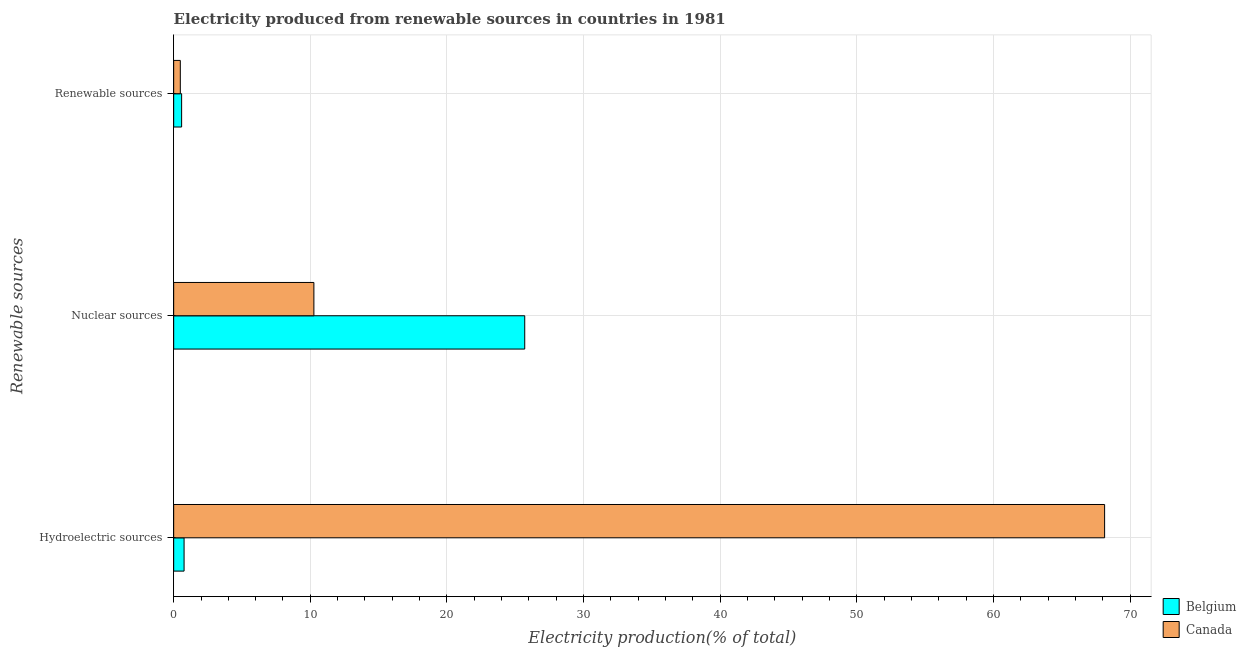How many bars are there on the 2nd tick from the top?
Keep it short and to the point. 2. What is the label of the 2nd group of bars from the top?
Keep it short and to the point. Nuclear sources. What is the percentage of electricity produced by renewable sources in Canada?
Provide a succinct answer. 0.49. Across all countries, what is the maximum percentage of electricity produced by nuclear sources?
Keep it short and to the point. 25.69. Across all countries, what is the minimum percentage of electricity produced by nuclear sources?
Your answer should be compact. 10.26. In which country was the percentage of electricity produced by nuclear sources minimum?
Make the answer very short. Canada. What is the total percentage of electricity produced by hydroelectric sources in the graph?
Offer a very short reply. 68.89. What is the difference between the percentage of electricity produced by renewable sources in Canada and that in Belgium?
Provide a succinct answer. -0.1. What is the difference between the percentage of electricity produced by nuclear sources in Belgium and the percentage of electricity produced by hydroelectric sources in Canada?
Provide a short and direct response. -42.44. What is the average percentage of electricity produced by renewable sources per country?
Your answer should be very brief. 0.53. What is the difference between the percentage of electricity produced by nuclear sources and percentage of electricity produced by renewable sources in Canada?
Offer a terse response. 9.78. What is the ratio of the percentage of electricity produced by renewable sources in Belgium to that in Canada?
Keep it short and to the point. 1.2. Is the difference between the percentage of electricity produced by hydroelectric sources in Canada and Belgium greater than the difference between the percentage of electricity produced by renewable sources in Canada and Belgium?
Offer a terse response. Yes. What is the difference between the highest and the second highest percentage of electricity produced by hydroelectric sources?
Your response must be concise. 67.37. What is the difference between the highest and the lowest percentage of electricity produced by nuclear sources?
Keep it short and to the point. 15.43. What does the 1st bar from the top in Renewable sources represents?
Give a very brief answer. Canada. How many bars are there?
Give a very brief answer. 6. Are the values on the major ticks of X-axis written in scientific E-notation?
Give a very brief answer. No. Where does the legend appear in the graph?
Offer a very short reply. Bottom right. How are the legend labels stacked?
Ensure brevity in your answer.  Vertical. What is the title of the graph?
Offer a terse response. Electricity produced from renewable sources in countries in 1981. Does "Australia" appear as one of the legend labels in the graph?
Ensure brevity in your answer.  No. What is the label or title of the X-axis?
Provide a short and direct response. Electricity production(% of total). What is the label or title of the Y-axis?
Provide a short and direct response. Renewable sources. What is the Electricity production(% of total) of Belgium in Hydroelectric sources?
Provide a succinct answer. 0.76. What is the Electricity production(% of total) in Canada in Hydroelectric sources?
Your response must be concise. 68.13. What is the Electricity production(% of total) of Belgium in Nuclear sources?
Your answer should be very brief. 25.69. What is the Electricity production(% of total) of Canada in Nuclear sources?
Offer a terse response. 10.26. What is the Electricity production(% of total) in Belgium in Renewable sources?
Your answer should be compact. 0.58. What is the Electricity production(% of total) of Canada in Renewable sources?
Give a very brief answer. 0.49. Across all Renewable sources, what is the maximum Electricity production(% of total) of Belgium?
Make the answer very short. 25.69. Across all Renewable sources, what is the maximum Electricity production(% of total) of Canada?
Offer a terse response. 68.13. Across all Renewable sources, what is the minimum Electricity production(% of total) in Belgium?
Ensure brevity in your answer.  0.58. Across all Renewable sources, what is the minimum Electricity production(% of total) in Canada?
Your response must be concise. 0.49. What is the total Electricity production(% of total) in Belgium in the graph?
Provide a succinct answer. 27.03. What is the total Electricity production(% of total) in Canada in the graph?
Offer a very short reply. 78.88. What is the difference between the Electricity production(% of total) of Belgium in Hydroelectric sources and that in Nuclear sources?
Provide a short and direct response. -24.93. What is the difference between the Electricity production(% of total) of Canada in Hydroelectric sources and that in Nuclear sources?
Your answer should be very brief. 57.87. What is the difference between the Electricity production(% of total) in Belgium in Hydroelectric sources and that in Renewable sources?
Give a very brief answer. 0.18. What is the difference between the Electricity production(% of total) in Canada in Hydroelectric sources and that in Renewable sources?
Your response must be concise. 67.64. What is the difference between the Electricity production(% of total) in Belgium in Nuclear sources and that in Renewable sources?
Your response must be concise. 25.11. What is the difference between the Electricity production(% of total) in Canada in Nuclear sources and that in Renewable sources?
Ensure brevity in your answer.  9.78. What is the difference between the Electricity production(% of total) of Belgium in Hydroelectric sources and the Electricity production(% of total) of Canada in Nuclear sources?
Provide a succinct answer. -9.5. What is the difference between the Electricity production(% of total) of Belgium in Hydroelectric sources and the Electricity production(% of total) of Canada in Renewable sources?
Keep it short and to the point. 0.28. What is the difference between the Electricity production(% of total) of Belgium in Nuclear sources and the Electricity production(% of total) of Canada in Renewable sources?
Give a very brief answer. 25.21. What is the average Electricity production(% of total) of Belgium per Renewable sources?
Give a very brief answer. 9.01. What is the average Electricity production(% of total) in Canada per Renewable sources?
Ensure brevity in your answer.  26.29. What is the difference between the Electricity production(% of total) of Belgium and Electricity production(% of total) of Canada in Hydroelectric sources?
Offer a terse response. -67.37. What is the difference between the Electricity production(% of total) of Belgium and Electricity production(% of total) of Canada in Nuclear sources?
Ensure brevity in your answer.  15.43. What is the difference between the Electricity production(% of total) of Belgium and Electricity production(% of total) of Canada in Renewable sources?
Ensure brevity in your answer.  0.1. What is the ratio of the Electricity production(% of total) in Belgium in Hydroelectric sources to that in Nuclear sources?
Your response must be concise. 0.03. What is the ratio of the Electricity production(% of total) of Canada in Hydroelectric sources to that in Nuclear sources?
Provide a succinct answer. 6.64. What is the ratio of the Electricity production(% of total) in Belgium in Hydroelectric sources to that in Renewable sources?
Your response must be concise. 1.31. What is the ratio of the Electricity production(% of total) in Canada in Hydroelectric sources to that in Renewable sources?
Keep it short and to the point. 140.16. What is the ratio of the Electricity production(% of total) in Belgium in Nuclear sources to that in Renewable sources?
Offer a terse response. 44.19. What is the ratio of the Electricity production(% of total) in Canada in Nuclear sources to that in Renewable sources?
Offer a very short reply. 21.11. What is the difference between the highest and the second highest Electricity production(% of total) in Belgium?
Provide a succinct answer. 24.93. What is the difference between the highest and the second highest Electricity production(% of total) of Canada?
Your answer should be compact. 57.87. What is the difference between the highest and the lowest Electricity production(% of total) in Belgium?
Make the answer very short. 25.11. What is the difference between the highest and the lowest Electricity production(% of total) of Canada?
Your answer should be compact. 67.64. 